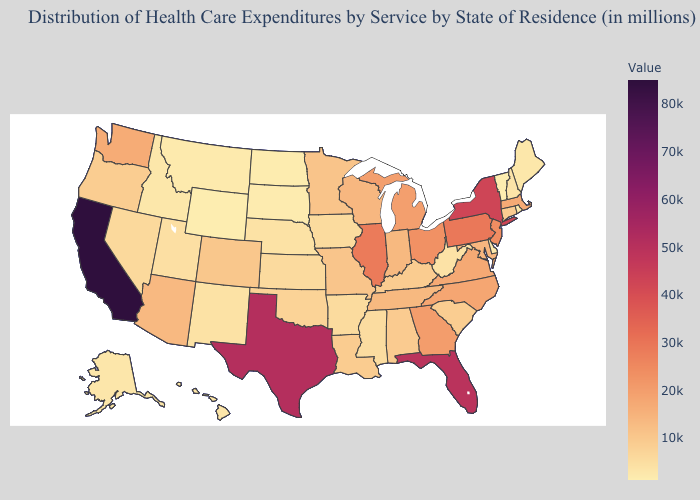Among the states that border Kansas , does Missouri have the lowest value?
Give a very brief answer. No. Does Kentucky have the highest value in the South?
Be succinct. No. Which states have the highest value in the USA?
Be succinct. California. Which states have the highest value in the USA?
Answer briefly. California. Among the states that border Washington , does Idaho have the lowest value?
Write a very short answer. Yes. Does Arkansas have the lowest value in the USA?
Keep it brief. No. 